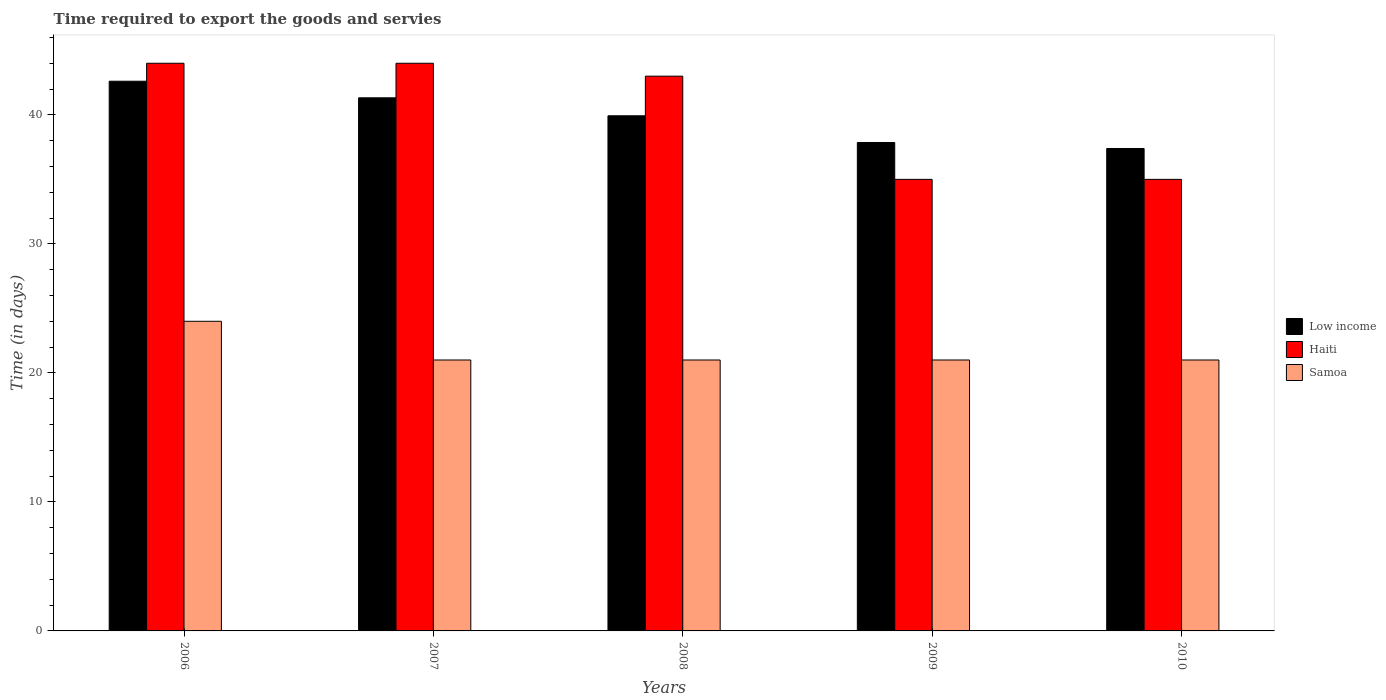How many bars are there on the 5th tick from the left?
Your answer should be compact. 3. How many bars are there on the 4th tick from the right?
Give a very brief answer. 3. What is the label of the 5th group of bars from the left?
Provide a short and direct response. 2010. In how many cases, is the number of bars for a given year not equal to the number of legend labels?
Offer a very short reply. 0. What is the number of days required to export the goods and services in Low income in 2010?
Give a very brief answer. 37.39. Across all years, what is the maximum number of days required to export the goods and services in Haiti?
Your answer should be compact. 44. Across all years, what is the minimum number of days required to export the goods and services in Low income?
Provide a succinct answer. 37.39. In which year was the number of days required to export the goods and services in Samoa maximum?
Give a very brief answer. 2006. In which year was the number of days required to export the goods and services in Samoa minimum?
Provide a succinct answer. 2007. What is the total number of days required to export the goods and services in Samoa in the graph?
Make the answer very short. 108. What is the difference between the number of days required to export the goods and services in Samoa in 2006 and that in 2007?
Offer a very short reply. 3. What is the difference between the number of days required to export the goods and services in Samoa in 2007 and the number of days required to export the goods and services in Haiti in 2008?
Keep it short and to the point. -22. What is the average number of days required to export the goods and services in Samoa per year?
Keep it short and to the point. 21.6. In the year 2008, what is the difference between the number of days required to export the goods and services in Haiti and number of days required to export the goods and services in Samoa?
Ensure brevity in your answer.  22. In how many years, is the number of days required to export the goods and services in Samoa greater than 14 days?
Keep it short and to the point. 5. What is the ratio of the number of days required to export the goods and services in Samoa in 2006 to that in 2009?
Offer a very short reply. 1.14. Is the number of days required to export the goods and services in Haiti in 2006 less than that in 2009?
Make the answer very short. No. What is the difference between the highest and the second highest number of days required to export the goods and services in Haiti?
Make the answer very short. 0. What is the difference between the highest and the lowest number of days required to export the goods and services in Samoa?
Give a very brief answer. 3. In how many years, is the number of days required to export the goods and services in Low income greater than the average number of days required to export the goods and services in Low income taken over all years?
Make the answer very short. 3. What does the 2nd bar from the left in 2006 represents?
Your response must be concise. Haiti. What does the 2nd bar from the right in 2010 represents?
Provide a short and direct response. Haiti. Are all the bars in the graph horizontal?
Offer a terse response. No. How many years are there in the graph?
Offer a terse response. 5. What is the title of the graph?
Give a very brief answer. Time required to export the goods and servies. Does "Latin America(all income levels)" appear as one of the legend labels in the graph?
Your answer should be compact. No. What is the label or title of the Y-axis?
Your answer should be compact. Time (in days). What is the Time (in days) in Low income in 2006?
Provide a short and direct response. 42.61. What is the Time (in days) in Haiti in 2006?
Keep it short and to the point. 44. What is the Time (in days) of Low income in 2007?
Ensure brevity in your answer.  41.32. What is the Time (in days) in Haiti in 2007?
Provide a short and direct response. 44. What is the Time (in days) of Samoa in 2007?
Offer a very short reply. 21. What is the Time (in days) of Low income in 2008?
Ensure brevity in your answer.  39.93. What is the Time (in days) of Haiti in 2008?
Your response must be concise. 43. What is the Time (in days) in Samoa in 2008?
Offer a terse response. 21. What is the Time (in days) of Low income in 2009?
Provide a short and direct response. 37.86. What is the Time (in days) in Haiti in 2009?
Ensure brevity in your answer.  35. What is the Time (in days) in Samoa in 2009?
Make the answer very short. 21. What is the Time (in days) in Low income in 2010?
Make the answer very short. 37.39. What is the Time (in days) in Haiti in 2010?
Your answer should be very brief. 35. Across all years, what is the maximum Time (in days) of Low income?
Offer a very short reply. 42.61. Across all years, what is the minimum Time (in days) in Low income?
Keep it short and to the point. 37.39. Across all years, what is the minimum Time (in days) of Haiti?
Give a very brief answer. 35. What is the total Time (in days) in Low income in the graph?
Ensure brevity in your answer.  199.11. What is the total Time (in days) of Haiti in the graph?
Ensure brevity in your answer.  201. What is the total Time (in days) in Samoa in the graph?
Your response must be concise. 108. What is the difference between the Time (in days) in Low income in 2006 and that in 2007?
Your response must be concise. 1.29. What is the difference between the Time (in days) of Haiti in 2006 and that in 2007?
Your answer should be compact. 0. What is the difference between the Time (in days) in Low income in 2006 and that in 2008?
Give a very brief answer. 2.68. What is the difference between the Time (in days) in Haiti in 2006 and that in 2008?
Keep it short and to the point. 1. What is the difference between the Time (in days) of Low income in 2006 and that in 2009?
Offer a terse response. 4.75. What is the difference between the Time (in days) in Haiti in 2006 and that in 2009?
Provide a short and direct response. 9. What is the difference between the Time (in days) in Samoa in 2006 and that in 2009?
Your response must be concise. 3. What is the difference between the Time (in days) of Low income in 2006 and that in 2010?
Ensure brevity in your answer.  5.21. What is the difference between the Time (in days) in Samoa in 2006 and that in 2010?
Provide a succinct answer. 3. What is the difference between the Time (in days) of Low income in 2007 and that in 2008?
Provide a short and direct response. 1.39. What is the difference between the Time (in days) of Samoa in 2007 and that in 2008?
Provide a short and direct response. 0. What is the difference between the Time (in days) in Low income in 2007 and that in 2009?
Give a very brief answer. 3.46. What is the difference between the Time (in days) of Haiti in 2007 and that in 2009?
Your answer should be compact. 9. What is the difference between the Time (in days) in Samoa in 2007 and that in 2009?
Offer a terse response. 0. What is the difference between the Time (in days) in Low income in 2007 and that in 2010?
Make the answer very short. 3.93. What is the difference between the Time (in days) in Haiti in 2007 and that in 2010?
Offer a very short reply. 9. What is the difference between the Time (in days) of Low income in 2008 and that in 2009?
Your answer should be compact. 2.07. What is the difference between the Time (in days) in Low income in 2008 and that in 2010?
Make the answer very short. 2.54. What is the difference between the Time (in days) of Low income in 2009 and that in 2010?
Provide a short and direct response. 0.46. What is the difference between the Time (in days) of Haiti in 2009 and that in 2010?
Offer a very short reply. 0. What is the difference between the Time (in days) in Low income in 2006 and the Time (in days) in Haiti in 2007?
Keep it short and to the point. -1.39. What is the difference between the Time (in days) in Low income in 2006 and the Time (in days) in Samoa in 2007?
Keep it short and to the point. 21.61. What is the difference between the Time (in days) of Haiti in 2006 and the Time (in days) of Samoa in 2007?
Offer a very short reply. 23. What is the difference between the Time (in days) in Low income in 2006 and the Time (in days) in Haiti in 2008?
Your answer should be compact. -0.39. What is the difference between the Time (in days) in Low income in 2006 and the Time (in days) in Samoa in 2008?
Provide a succinct answer. 21.61. What is the difference between the Time (in days) of Low income in 2006 and the Time (in days) of Haiti in 2009?
Give a very brief answer. 7.61. What is the difference between the Time (in days) of Low income in 2006 and the Time (in days) of Samoa in 2009?
Your answer should be compact. 21.61. What is the difference between the Time (in days) of Haiti in 2006 and the Time (in days) of Samoa in 2009?
Keep it short and to the point. 23. What is the difference between the Time (in days) of Low income in 2006 and the Time (in days) of Haiti in 2010?
Make the answer very short. 7.61. What is the difference between the Time (in days) of Low income in 2006 and the Time (in days) of Samoa in 2010?
Your answer should be very brief. 21.61. What is the difference between the Time (in days) of Haiti in 2006 and the Time (in days) of Samoa in 2010?
Provide a succinct answer. 23. What is the difference between the Time (in days) in Low income in 2007 and the Time (in days) in Haiti in 2008?
Provide a short and direct response. -1.68. What is the difference between the Time (in days) of Low income in 2007 and the Time (in days) of Samoa in 2008?
Provide a succinct answer. 20.32. What is the difference between the Time (in days) of Low income in 2007 and the Time (in days) of Haiti in 2009?
Make the answer very short. 6.32. What is the difference between the Time (in days) of Low income in 2007 and the Time (in days) of Samoa in 2009?
Offer a very short reply. 20.32. What is the difference between the Time (in days) of Haiti in 2007 and the Time (in days) of Samoa in 2009?
Give a very brief answer. 23. What is the difference between the Time (in days) of Low income in 2007 and the Time (in days) of Haiti in 2010?
Your answer should be compact. 6.32. What is the difference between the Time (in days) of Low income in 2007 and the Time (in days) of Samoa in 2010?
Ensure brevity in your answer.  20.32. What is the difference between the Time (in days) of Low income in 2008 and the Time (in days) of Haiti in 2009?
Your answer should be very brief. 4.93. What is the difference between the Time (in days) in Low income in 2008 and the Time (in days) in Samoa in 2009?
Provide a succinct answer. 18.93. What is the difference between the Time (in days) in Low income in 2008 and the Time (in days) in Haiti in 2010?
Offer a very short reply. 4.93. What is the difference between the Time (in days) in Low income in 2008 and the Time (in days) in Samoa in 2010?
Offer a very short reply. 18.93. What is the difference between the Time (in days) of Low income in 2009 and the Time (in days) of Haiti in 2010?
Make the answer very short. 2.86. What is the difference between the Time (in days) of Low income in 2009 and the Time (in days) of Samoa in 2010?
Keep it short and to the point. 16.86. What is the difference between the Time (in days) in Haiti in 2009 and the Time (in days) in Samoa in 2010?
Offer a very short reply. 14. What is the average Time (in days) in Low income per year?
Keep it short and to the point. 39.82. What is the average Time (in days) of Haiti per year?
Your answer should be compact. 40.2. What is the average Time (in days) of Samoa per year?
Your response must be concise. 21.6. In the year 2006, what is the difference between the Time (in days) in Low income and Time (in days) in Haiti?
Give a very brief answer. -1.39. In the year 2006, what is the difference between the Time (in days) of Low income and Time (in days) of Samoa?
Give a very brief answer. 18.61. In the year 2006, what is the difference between the Time (in days) in Haiti and Time (in days) in Samoa?
Give a very brief answer. 20. In the year 2007, what is the difference between the Time (in days) of Low income and Time (in days) of Haiti?
Offer a terse response. -2.68. In the year 2007, what is the difference between the Time (in days) in Low income and Time (in days) in Samoa?
Give a very brief answer. 20.32. In the year 2007, what is the difference between the Time (in days) in Haiti and Time (in days) in Samoa?
Your answer should be compact. 23. In the year 2008, what is the difference between the Time (in days) in Low income and Time (in days) in Haiti?
Your answer should be very brief. -3.07. In the year 2008, what is the difference between the Time (in days) of Low income and Time (in days) of Samoa?
Keep it short and to the point. 18.93. In the year 2008, what is the difference between the Time (in days) in Haiti and Time (in days) in Samoa?
Offer a terse response. 22. In the year 2009, what is the difference between the Time (in days) in Low income and Time (in days) in Haiti?
Provide a succinct answer. 2.86. In the year 2009, what is the difference between the Time (in days) of Low income and Time (in days) of Samoa?
Make the answer very short. 16.86. In the year 2009, what is the difference between the Time (in days) in Haiti and Time (in days) in Samoa?
Keep it short and to the point. 14. In the year 2010, what is the difference between the Time (in days) in Low income and Time (in days) in Haiti?
Your response must be concise. 2.39. In the year 2010, what is the difference between the Time (in days) of Low income and Time (in days) of Samoa?
Provide a succinct answer. 16.39. In the year 2010, what is the difference between the Time (in days) of Haiti and Time (in days) of Samoa?
Your answer should be very brief. 14. What is the ratio of the Time (in days) of Low income in 2006 to that in 2007?
Give a very brief answer. 1.03. What is the ratio of the Time (in days) in Haiti in 2006 to that in 2007?
Offer a very short reply. 1. What is the ratio of the Time (in days) of Low income in 2006 to that in 2008?
Provide a short and direct response. 1.07. What is the ratio of the Time (in days) in Haiti in 2006 to that in 2008?
Make the answer very short. 1.02. What is the ratio of the Time (in days) of Samoa in 2006 to that in 2008?
Keep it short and to the point. 1.14. What is the ratio of the Time (in days) in Low income in 2006 to that in 2009?
Your answer should be very brief. 1.13. What is the ratio of the Time (in days) in Haiti in 2006 to that in 2009?
Provide a short and direct response. 1.26. What is the ratio of the Time (in days) of Samoa in 2006 to that in 2009?
Make the answer very short. 1.14. What is the ratio of the Time (in days) of Low income in 2006 to that in 2010?
Keep it short and to the point. 1.14. What is the ratio of the Time (in days) in Haiti in 2006 to that in 2010?
Your response must be concise. 1.26. What is the ratio of the Time (in days) in Low income in 2007 to that in 2008?
Provide a succinct answer. 1.03. What is the ratio of the Time (in days) of Haiti in 2007 to that in 2008?
Give a very brief answer. 1.02. What is the ratio of the Time (in days) of Low income in 2007 to that in 2009?
Keep it short and to the point. 1.09. What is the ratio of the Time (in days) of Haiti in 2007 to that in 2009?
Offer a very short reply. 1.26. What is the ratio of the Time (in days) in Samoa in 2007 to that in 2009?
Provide a short and direct response. 1. What is the ratio of the Time (in days) of Low income in 2007 to that in 2010?
Make the answer very short. 1.11. What is the ratio of the Time (in days) of Haiti in 2007 to that in 2010?
Offer a very short reply. 1.26. What is the ratio of the Time (in days) in Samoa in 2007 to that in 2010?
Provide a succinct answer. 1. What is the ratio of the Time (in days) in Low income in 2008 to that in 2009?
Your answer should be compact. 1.05. What is the ratio of the Time (in days) in Haiti in 2008 to that in 2009?
Provide a succinct answer. 1.23. What is the ratio of the Time (in days) of Low income in 2008 to that in 2010?
Keep it short and to the point. 1.07. What is the ratio of the Time (in days) in Haiti in 2008 to that in 2010?
Your response must be concise. 1.23. What is the ratio of the Time (in days) of Low income in 2009 to that in 2010?
Your answer should be very brief. 1.01. What is the ratio of the Time (in days) of Haiti in 2009 to that in 2010?
Keep it short and to the point. 1. What is the difference between the highest and the second highest Time (in days) in Low income?
Provide a short and direct response. 1.29. What is the difference between the highest and the lowest Time (in days) in Low income?
Your response must be concise. 5.21. What is the difference between the highest and the lowest Time (in days) of Haiti?
Offer a terse response. 9. 